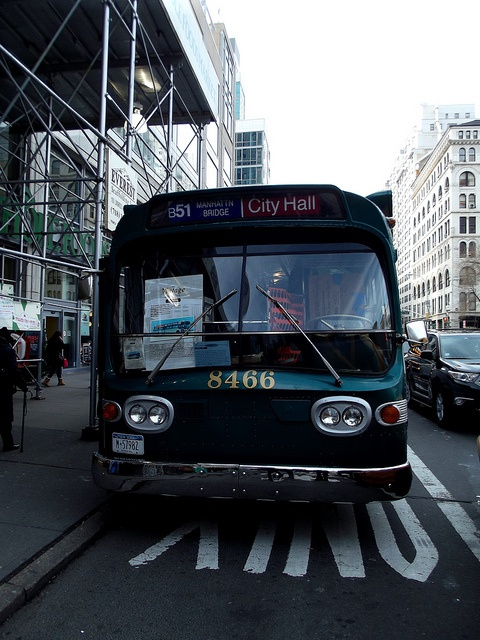Describe the objects in this image and their specific colors. I can see bus in black, gray, blue, and darkblue tones, car in black, gray, and darkgray tones, people in black, gray, and maroon tones, and people in black, gray, and maroon tones in this image. 